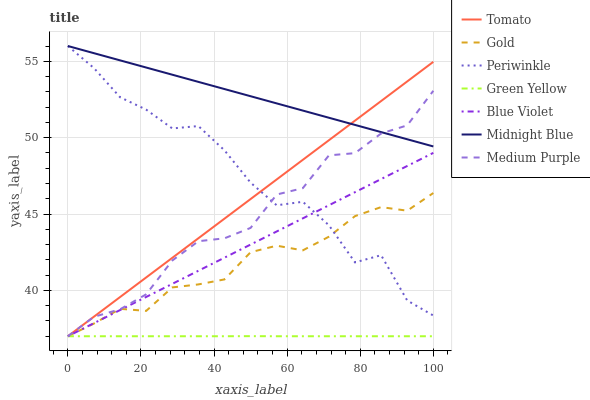Does Green Yellow have the minimum area under the curve?
Answer yes or no. Yes. Does Midnight Blue have the maximum area under the curve?
Answer yes or no. Yes. Does Gold have the minimum area under the curve?
Answer yes or no. No. Does Gold have the maximum area under the curve?
Answer yes or no. No. Is Midnight Blue the smoothest?
Answer yes or no. Yes. Is Periwinkle the roughest?
Answer yes or no. Yes. Is Gold the smoothest?
Answer yes or no. No. Is Gold the roughest?
Answer yes or no. No. Does Tomato have the lowest value?
Answer yes or no. Yes. Does Midnight Blue have the lowest value?
Answer yes or no. No. Does Periwinkle have the highest value?
Answer yes or no. Yes. Does Gold have the highest value?
Answer yes or no. No. Is Blue Violet less than Midnight Blue?
Answer yes or no. Yes. Is Midnight Blue greater than Gold?
Answer yes or no. Yes. Does Medium Purple intersect Midnight Blue?
Answer yes or no. Yes. Is Medium Purple less than Midnight Blue?
Answer yes or no. No. Is Medium Purple greater than Midnight Blue?
Answer yes or no. No. Does Blue Violet intersect Midnight Blue?
Answer yes or no. No. 